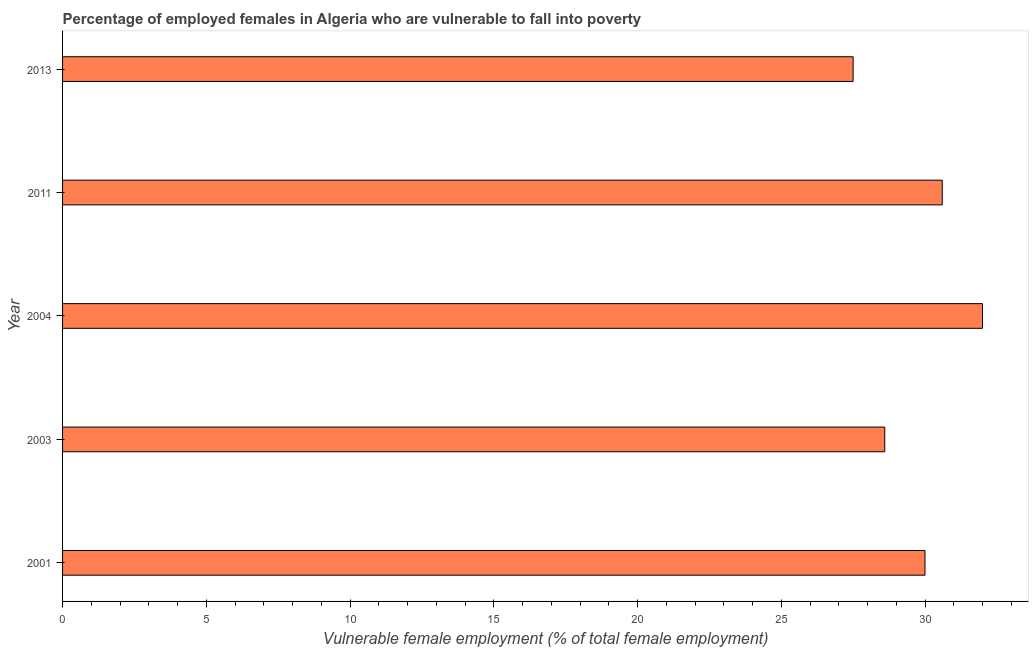Does the graph contain any zero values?
Provide a succinct answer. No. Does the graph contain grids?
Your answer should be very brief. No. What is the title of the graph?
Give a very brief answer. Percentage of employed females in Algeria who are vulnerable to fall into poverty. What is the label or title of the X-axis?
Your answer should be very brief. Vulnerable female employment (% of total female employment). Across all years, what is the maximum percentage of employed females who are vulnerable to fall into poverty?
Ensure brevity in your answer.  32. Across all years, what is the minimum percentage of employed females who are vulnerable to fall into poverty?
Ensure brevity in your answer.  27.5. In which year was the percentage of employed females who are vulnerable to fall into poverty maximum?
Your answer should be compact. 2004. In which year was the percentage of employed females who are vulnerable to fall into poverty minimum?
Your answer should be very brief. 2013. What is the sum of the percentage of employed females who are vulnerable to fall into poverty?
Provide a succinct answer. 148.7. What is the average percentage of employed females who are vulnerable to fall into poverty per year?
Offer a very short reply. 29.74. In how many years, is the percentage of employed females who are vulnerable to fall into poverty greater than 25 %?
Keep it short and to the point. 5. Do a majority of the years between 2001 and 2004 (inclusive) have percentage of employed females who are vulnerable to fall into poverty greater than 25 %?
Your answer should be very brief. Yes. What is the ratio of the percentage of employed females who are vulnerable to fall into poverty in 2001 to that in 2004?
Give a very brief answer. 0.94. Is the difference between the percentage of employed females who are vulnerable to fall into poverty in 2011 and 2013 greater than the difference between any two years?
Your response must be concise. No. What is the difference between the highest and the lowest percentage of employed females who are vulnerable to fall into poverty?
Offer a terse response. 4.5. How many bars are there?
Keep it short and to the point. 5. Are all the bars in the graph horizontal?
Give a very brief answer. Yes. What is the difference between two consecutive major ticks on the X-axis?
Make the answer very short. 5. Are the values on the major ticks of X-axis written in scientific E-notation?
Offer a very short reply. No. What is the Vulnerable female employment (% of total female employment) in 2003?
Your answer should be very brief. 28.6. What is the Vulnerable female employment (% of total female employment) of 2004?
Offer a very short reply. 32. What is the Vulnerable female employment (% of total female employment) of 2011?
Offer a very short reply. 30.6. What is the difference between the Vulnerable female employment (% of total female employment) in 2001 and 2011?
Provide a short and direct response. -0.6. What is the difference between the Vulnerable female employment (% of total female employment) in 2001 and 2013?
Make the answer very short. 2.5. What is the difference between the Vulnerable female employment (% of total female employment) in 2003 and 2011?
Offer a very short reply. -2. What is the difference between the Vulnerable female employment (% of total female employment) in 2004 and 2013?
Offer a very short reply. 4.5. What is the difference between the Vulnerable female employment (% of total female employment) in 2011 and 2013?
Offer a terse response. 3.1. What is the ratio of the Vulnerable female employment (% of total female employment) in 2001 to that in 2003?
Your answer should be compact. 1.05. What is the ratio of the Vulnerable female employment (% of total female employment) in 2001 to that in 2004?
Ensure brevity in your answer.  0.94. What is the ratio of the Vulnerable female employment (% of total female employment) in 2001 to that in 2013?
Offer a very short reply. 1.09. What is the ratio of the Vulnerable female employment (% of total female employment) in 2003 to that in 2004?
Provide a short and direct response. 0.89. What is the ratio of the Vulnerable female employment (% of total female employment) in 2003 to that in 2011?
Offer a very short reply. 0.94. What is the ratio of the Vulnerable female employment (% of total female employment) in 2003 to that in 2013?
Make the answer very short. 1.04. What is the ratio of the Vulnerable female employment (% of total female employment) in 2004 to that in 2011?
Ensure brevity in your answer.  1.05. What is the ratio of the Vulnerable female employment (% of total female employment) in 2004 to that in 2013?
Make the answer very short. 1.16. What is the ratio of the Vulnerable female employment (% of total female employment) in 2011 to that in 2013?
Make the answer very short. 1.11. 